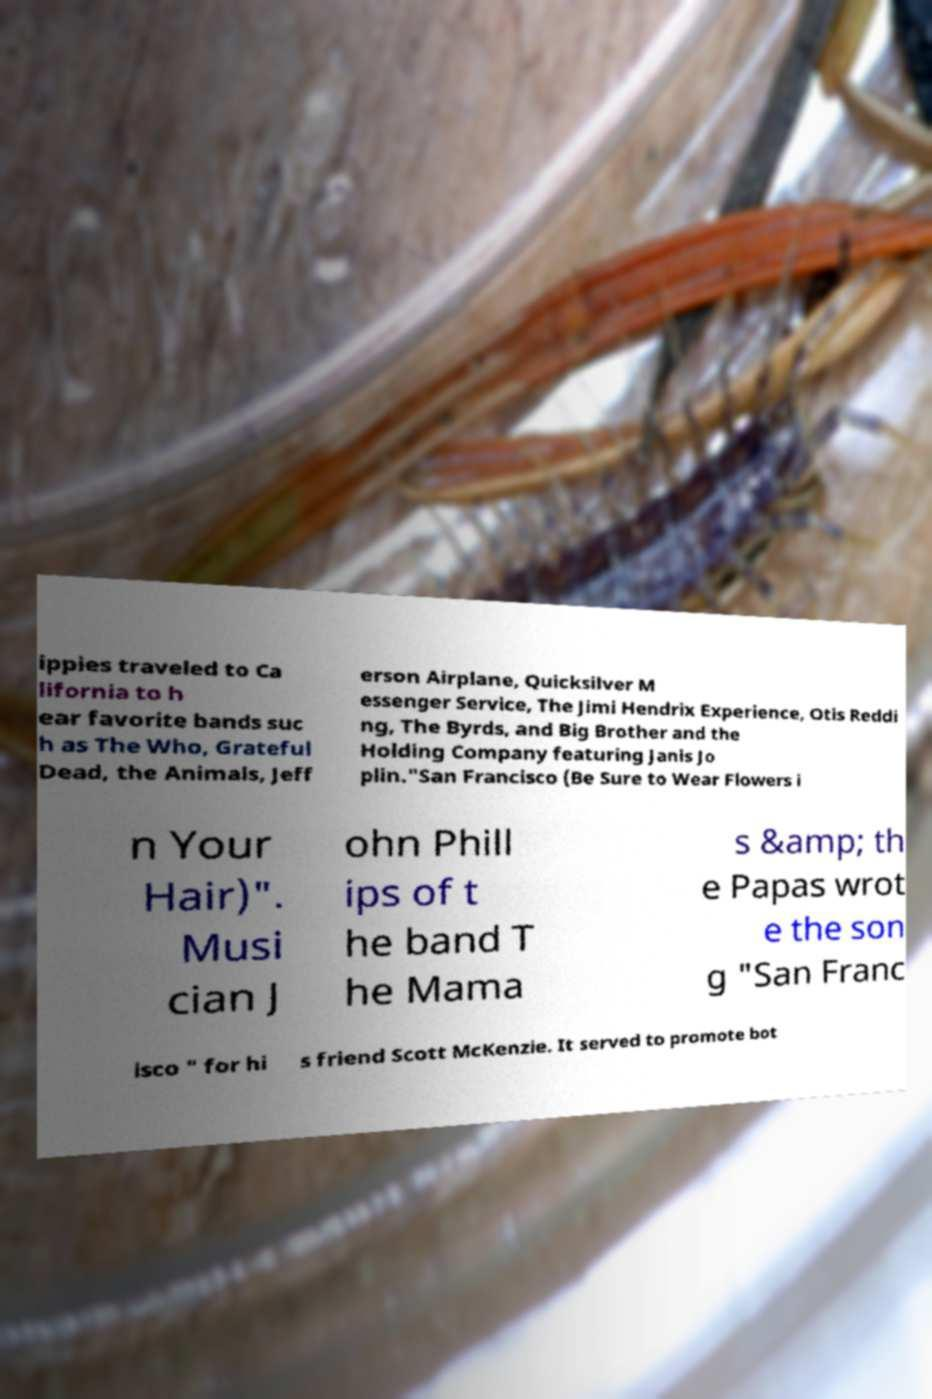Can you accurately transcribe the text from the provided image for me? ippies traveled to Ca lifornia to h ear favorite bands suc h as The Who, Grateful Dead, the Animals, Jeff erson Airplane, Quicksilver M essenger Service, The Jimi Hendrix Experience, Otis Reddi ng, The Byrds, and Big Brother and the Holding Company featuring Janis Jo plin."San Francisco (Be Sure to Wear Flowers i n Your Hair)". Musi cian J ohn Phill ips of t he band T he Mama s &amp; th e Papas wrot e the son g "San Franc isco " for hi s friend Scott McKenzie. It served to promote bot 